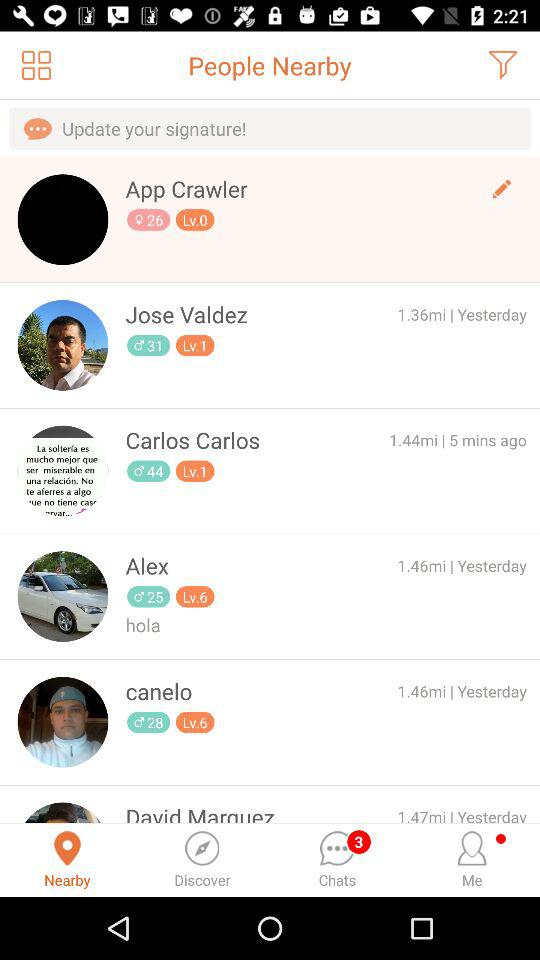Who is 1.36 miles away? The person who is 1.36 miles away is Jose Valdez. 